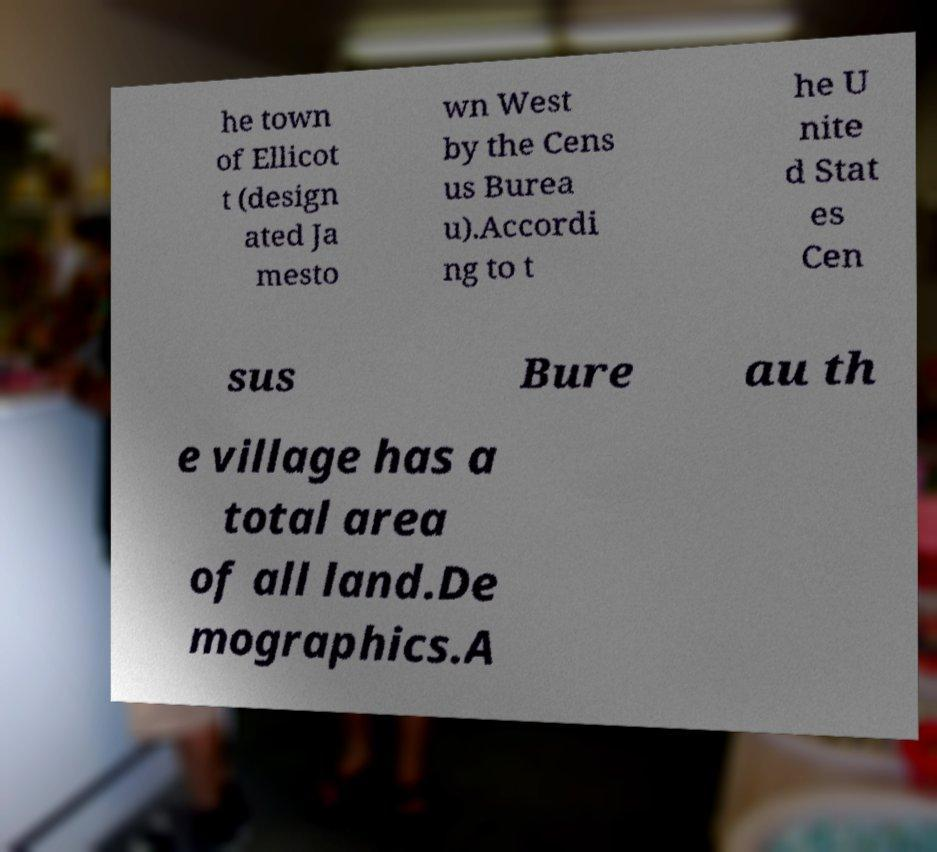Can you read and provide the text displayed in the image?This photo seems to have some interesting text. Can you extract and type it out for me? he town of Ellicot t (design ated Ja mesto wn West by the Cens us Burea u).Accordi ng to t he U nite d Stat es Cen sus Bure au th e village has a total area of all land.De mographics.A 